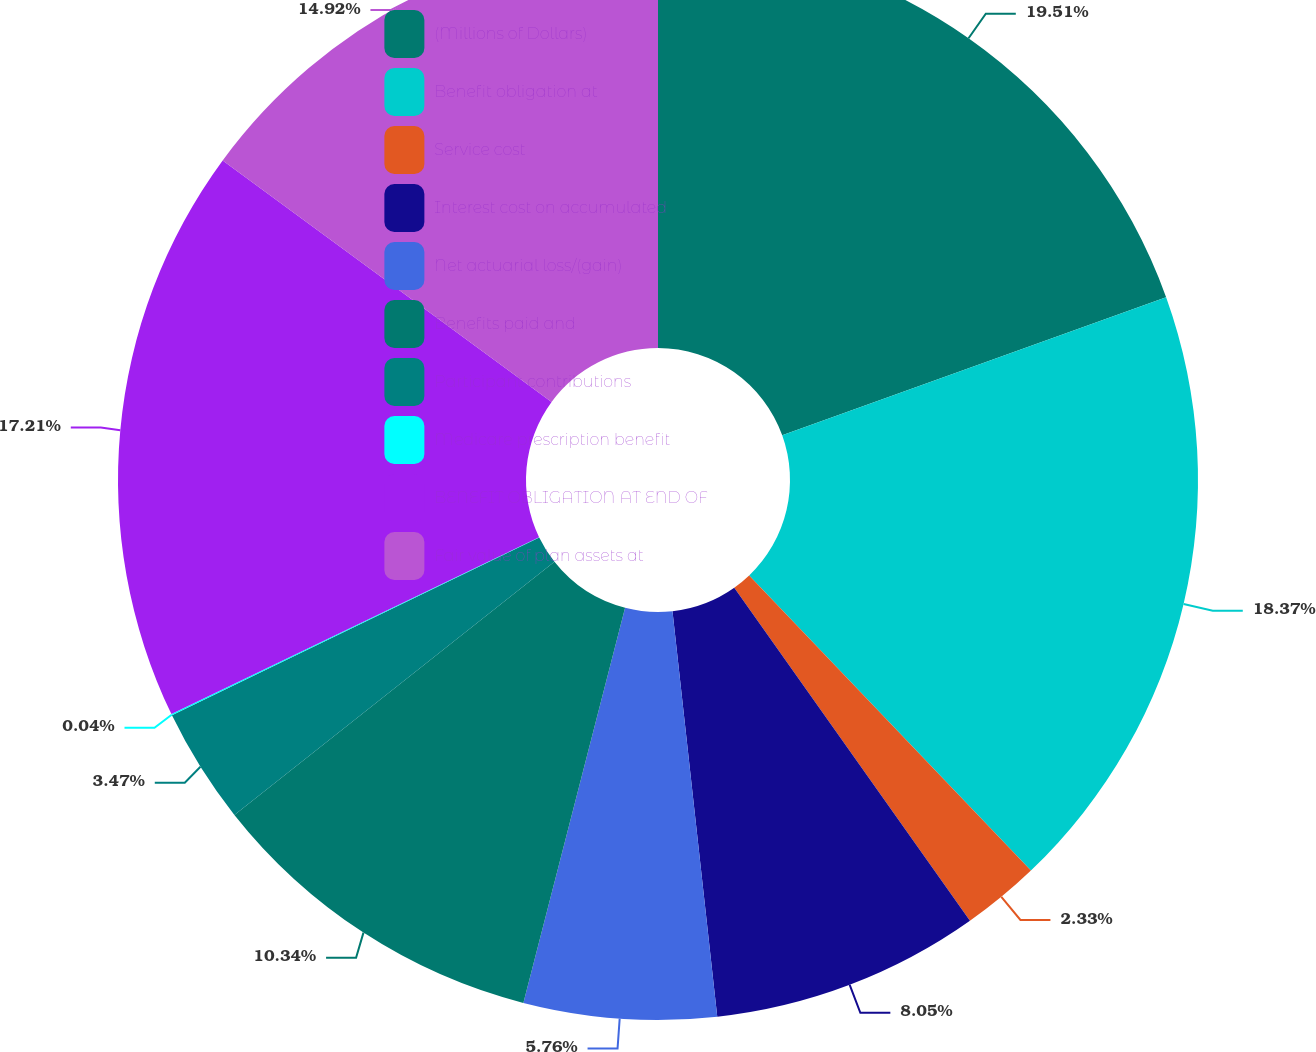Convert chart to OTSL. <chart><loc_0><loc_0><loc_500><loc_500><pie_chart><fcel>(Millions of Dollars)<fcel>Benefit obligation at<fcel>Service cost<fcel>Interest cost on accumulated<fcel>Net actuarial loss/(gain)<fcel>Benefits paid and<fcel>Participant contributions<fcel>Medicare prescription benefit<fcel>BENEFIT OBLIGATION AT END OF<fcel>Fair value of plan assets at<nl><fcel>19.5%<fcel>18.36%<fcel>2.33%<fcel>8.05%<fcel>5.76%<fcel>10.34%<fcel>3.47%<fcel>0.04%<fcel>17.21%<fcel>14.92%<nl></chart> 